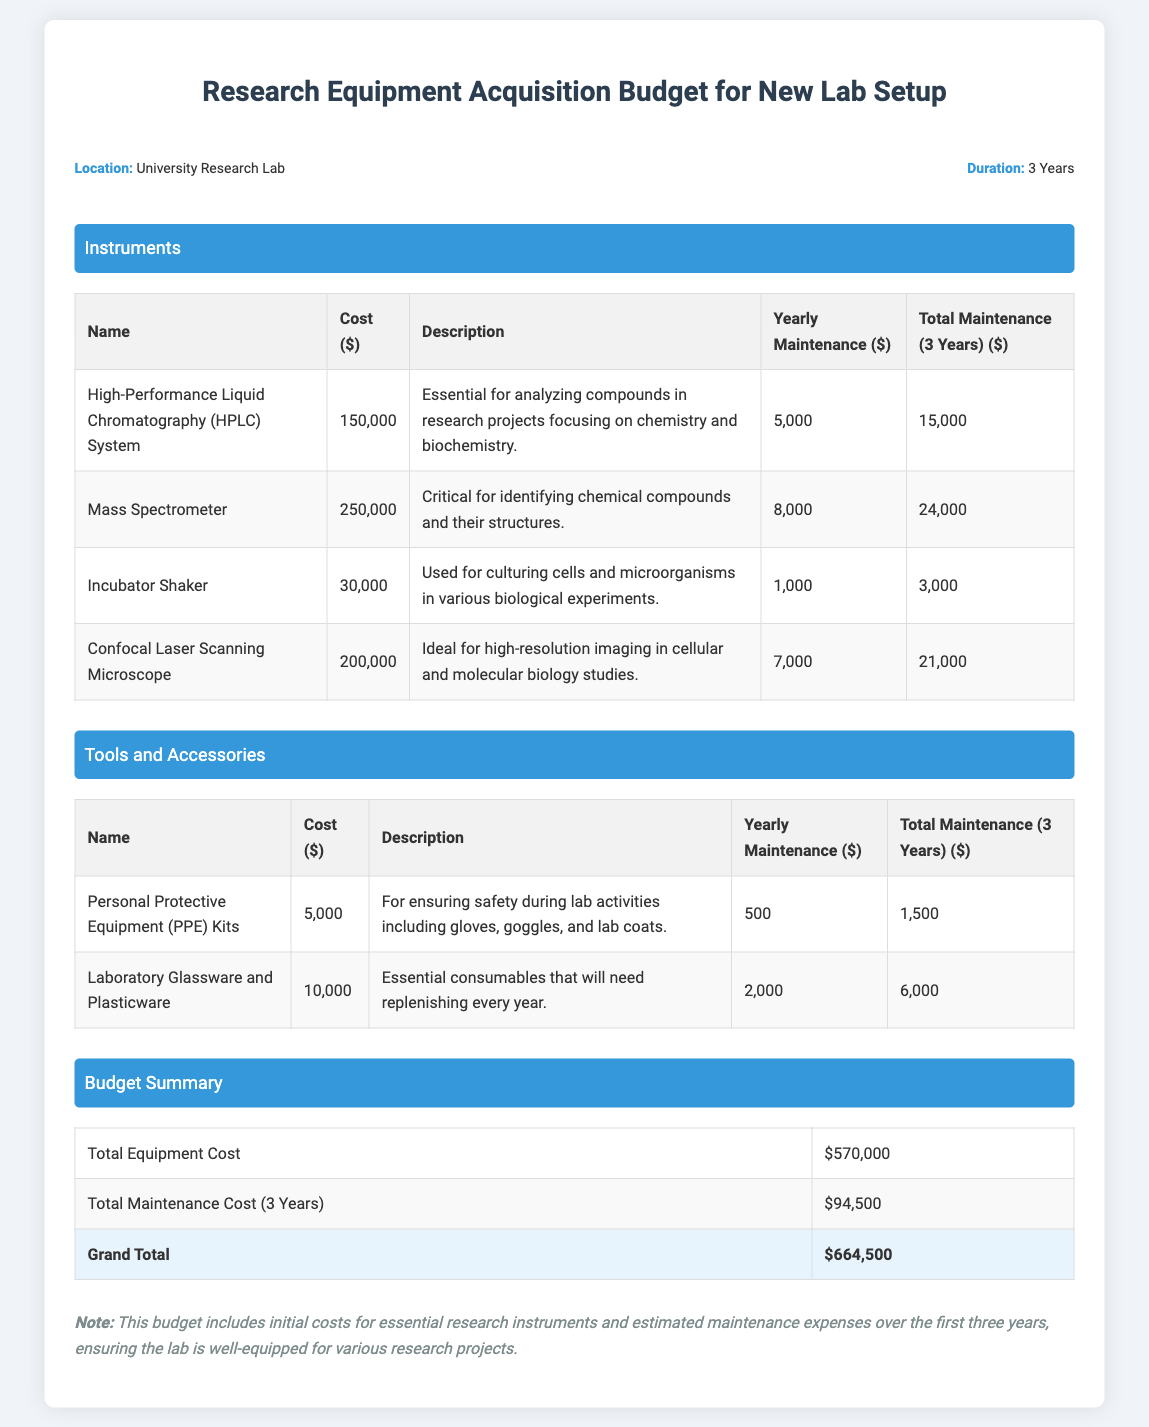What is the total equipment cost? The total equipment cost is stated in the budget summary section of the document.
Answer: $570,000 How much is the yearly maintenance for the Mass Spectrometer? This value can be found in the instruments table next to the Mass Spectrometer entry.
Answer: $8,000 What is the description of the Confocal Laser Scanning Microscope? The description is provided in the instruments table adjacent to the Confocal Laser Scanning Microscope entry.
Answer: Ideal for high-resolution imaging in cellular and molecular biology studies What is the total maintenance cost over three years? The total maintenance cost is calculated and provided in the budget summary section of the document.
Answer: $94,500 How many years does this budget cover? The duration is mentioned in the budget info section at the beginning of the document.
Answer: 3 Years What is included in the Personal Protective Equipment (PPE) Kits? The document briefly outlines the components of the PPE Kits in the tools and accessories section.
Answer: Gloves, goggles, and lab coats What is the grand total for the budget? The grand total is listed at the end of the budget summary table.
Answer: $664,500 What is the cost of the Incubator Shaker? The cost is specified in the instruments table next to the Incubator Shaker entry.
Answer: $30,000 What are laboratory glassware and plasticware classified as in this document? They are categorized in the tools and accessories section with a specific description.
Answer: Essential consumables What is the total maintenance for the HPLC System over three years? This total is calculated in the instruments table alongside the HPLC System entry.
Answer: $15,000 